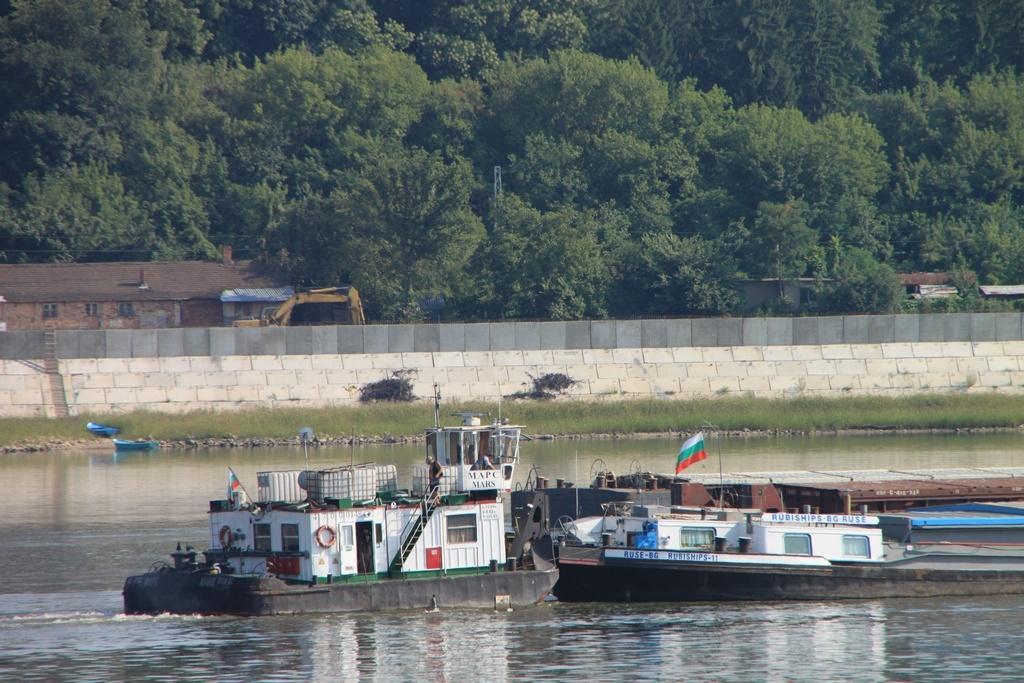In one or two sentences, can you explain what this image depicts? In this image we can see boats are floating on the water. Here we can see the flag, we can see grass, stone wall, houses, bulldozer and the trees in the background. 